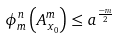Convert formula to latex. <formula><loc_0><loc_0><loc_500><loc_500>\phi ^ { n } _ { m } \left ( A ^ { m } _ { x _ { 0 } } \right ) \leq a ^ { \frac { - m } { 2 } }</formula> 